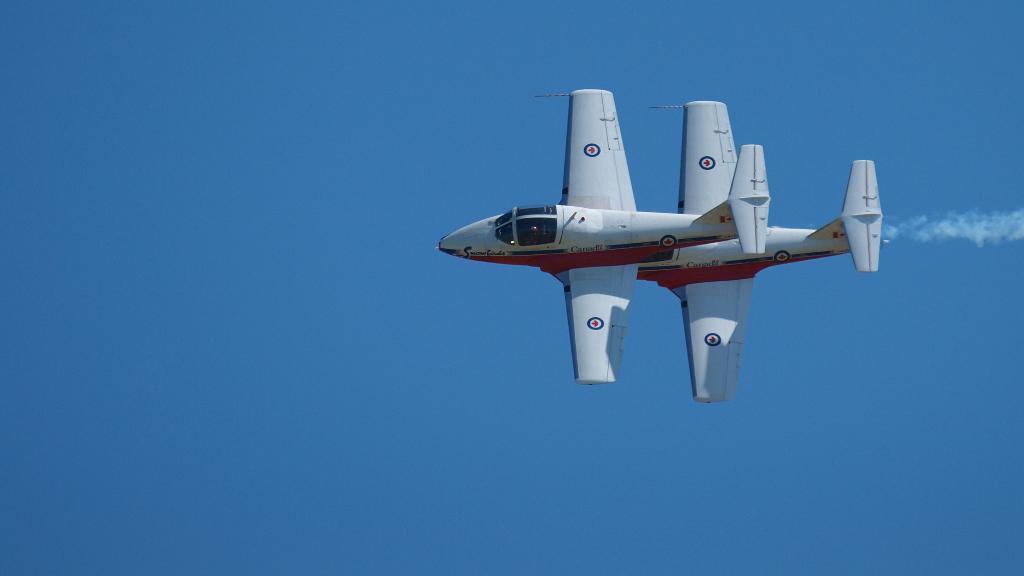Describe this image in one or two sentences. In this image there is a airplane in the sky. 